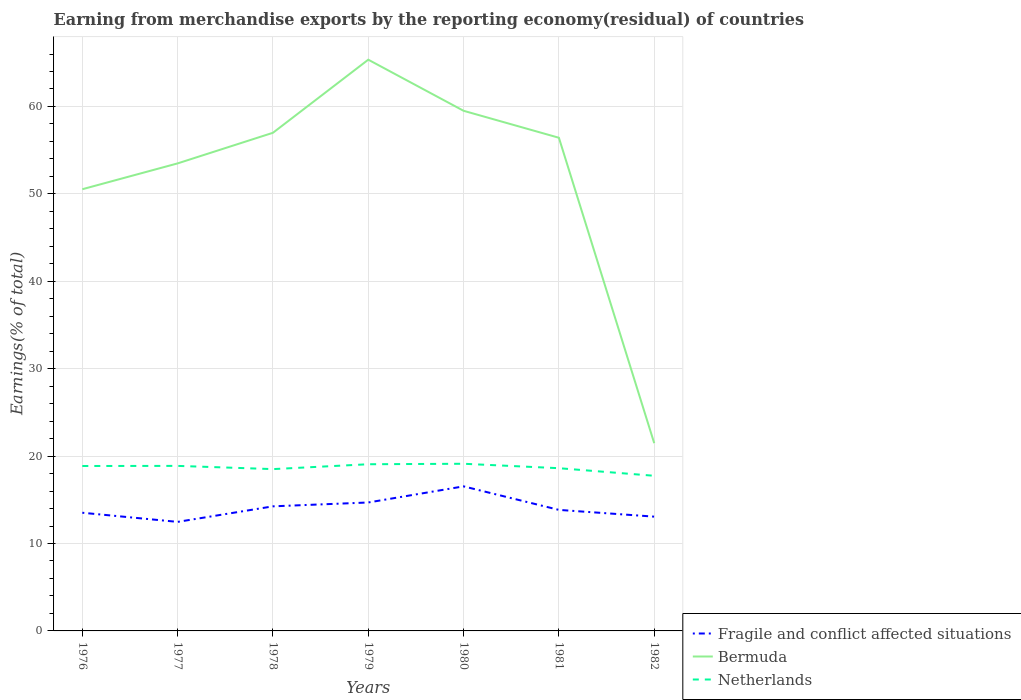How many different coloured lines are there?
Ensure brevity in your answer.  3. Across all years, what is the maximum percentage of amount earned from merchandise exports in Netherlands?
Provide a succinct answer. 17.75. In which year was the percentage of amount earned from merchandise exports in Netherlands maximum?
Your response must be concise. 1982. What is the total percentage of amount earned from merchandise exports in Fragile and conflict affected situations in the graph?
Make the answer very short. -0.73. What is the difference between the highest and the second highest percentage of amount earned from merchandise exports in Netherlands?
Ensure brevity in your answer.  1.38. Is the percentage of amount earned from merchandise exports in Netherlands strictly greater than the percentage of amount earned from merchandise exports in Bermuda over the years?
Offer a terse response. Yes. What is the difference between two consecutive major ticks on the Y-axis?
Offer a terse response. 10. How many legend labels are there?
Offer a very short reply. 3. What is the title of the graph?
Your answer should be very brief. Earning from merchandise exports by the reporting economy(residual) of countries. Does "Cabo Verde" appear as one of the legend labels in the graph?
Provide a short and direct response. No. What is the label or title of the X-axis?
Make the answer very short. Years. What is the label or title of the Y-axis?
Your response must be concise. Earnings(% of total). What is the Earnings(% of total) in Fragile and conflict affected situations in 1976?
Your answer should be very brief. 13.52. What is the Earnings(% of total) of Bermuda in 1976?
Your response must be concise. 50.53. What is the Earnings(% of total) of Netherlands in 1976?
Your answer should be compact. 18.87. What is the Earnings(% of total) of Fragile and conflict affected situations in 1977?
Provide a short and direct response. 12.48. What is the Earnings(% of total) in Bermuda in 1977?
Offer a terse response. 53.49. What is the Earnings(% of total) in Netherlands in 1977?
Offer a very short reply. 18.88. What is the Earnings(% of total) of Fragile and conflict affected situations in 1978?
Provide a succinct answer. 14.25. What is the Earnings(% of total) of Bermuda in 1978?
Make the answer very short. 56.99. What is the Earnings(% of total) in Netherlands in 1978?
Your response must be concise. 18.51. What is the Earnings(% of total) in Fragile and conflict affected situations in 1979?
Offer a very short reply. 14.69. What is the Earnings(% of total) of Bermuda in 1979?
Your answer should be very brief. 65.35. What is the Earnings(% of total) in Netherlands in 1979?
Give a very brief answer. 19.07. What is the Earnings(% of total) of Fragile and conflict affected situations in 1980?
Provide a short and direct response. 16.54. What is the Earnings(% of total) of Bermuda in 1980?
Keep it short and to the point. 59.51. What is the Earnings(% of total) in Netherlands in 1980?
Keep it short and to the point. 19.12. What is the Earnings(% of total) of Fragile and conflict affected situations in 1981?
Make the answer very short. 13.85. What is the Earnings(% of total) in Bermuda in 1981?
Offer a very short reply. 56.42. What is the Earnings(% of total) of Netherlands in 1981?
Your answer should be very brief. 18.62. What is the Earnings(% of total) in Fragile and conflict affected situations in 1982?
Give a very brief answer. 13.07. What is the Earnings(% of total) of Bermuda in 1982?
Provide a succinct answer. 21.48. What is the Earnings(% of total) in Netherlands in 1982?
Your answer should be very brief. 17.75. Across all years, what is the maximum Earnings(% of total) in Fragile and conflict affected situations?
Your response must be concise. 16.54. Across all years, what is the maximum Earnings(% of total) of Bermuda?
Your answer should be very brief. 65.35. Across all years, what is the maximum Earnings(% of total) of Netherlands?
Your response must be concise. 19.12. Across all years, what is the minimum Earnings(% of total) of Fragile and conflict affected situations?
Offer a very short reply. 12.48. Across all years, what is the minimum Earnings(% of total) of Bermuda?
Offer a very short reply. 21.48. Across all years, what is the minimum Earnings(% of total) of Netherlands?
Offer a very short reply. 17.75. What is the total Earnings(% of total) in Fragile and conflict affected situations in the graph?
Make the answer very short. 98.4. What is the total Earnings(% of total) in Bermuda in the graph?
Ensure brevity in your answer.  363.77. What is the total Earnings(% of total) of Netherlands in the graph?
Ensure brevity in your answer.  130.82. What is the difference between the Earnings(% of total) of Fragile and conflict affected situations in 1976 and that in 1977?
Provide a short and direct response. 1.05. What is the difference between the Earnings(% of total) in Bermuda in 1976 and that in 1977?
Give a very brief answer. -2.96. What is the difference between the Earnings(% of total) of Netherlands in 1976 and that in 1977?
Keep it short and to the point. -0.01. What is the difference between the Earnings(% of total) of Fragile and conflict affected situations in 1976 and that in 1978?
Offer a very short reply. -0.73. What is the difference between the Earnings(% of total) of Bermuda in 1976 and that in 1978?
Ensure brevity in your answer.  -6.46. What is the difference between the Earnings(% of total) in Netherlands in 1976 and that in 1978?
Make the answer very short. 0.36. What is the difference between the Earnings(% of total) in Fragile and conflict affected situations in 1976 and that in 1979?
Your answer should be very brief. -1.17. What is the difference between the Earnings(% of total) of Bermuda in 1976 and that in 1979?
Provide a succinct answer. -14.82. What is the difference between the Earnings(% of total) of Netherlands in 1976 and that in 1979?
Ensure brevity in your answer.  -0.2. What is the difference between the Earnings(% of total) in Fragile and conflict affected situations in 1976 and that in 1980?
Offer a very short reply. -3.02. What is the difference between the Earnings(% of total) in Bermuda in 1976 and that in 1980?
Ensure brevity in your answer.  -8.97. What is the difference between the Earnings(% of total) of Netherlands in 1976 and that in 1980?
Make the answer very short. -0.26. What is the difference between the Earnings(% of total) of Fragile and conflict affected situations in 1976 and that in 1981?
Your response must be concise. -0.33. What is the difference between the Earnings(% of total) in Bermuda in 1976 and that in 1981?
Your answer should be compact. -5.89. What is the difference between the Earnings(% of total) in Netherlands in 1976 and that in 1981?
Provide a short and direct response. 0.25. What is the difference between the Earnings(% of total) of Fragile and conflict affected situations in 1976 and that in 1982?
Your response must be concise. 0.45. What is the difference between the Earnings(% of total) of Bermuda in 1976 and that in 1982?
Provide a short and direct response. 29.05. What is the difference between the Earnings(% of total) in Netherlands in 1976 and that in 1982?
Your answer should be compact. 1.12. What is the difference between the Earnings(% of total) of Fragile and conflict affected situations in 1977 and that in 1978?
Your answer should be very brief. -1.78. What is the difference between the Earnings(% of total) of Bermuda in 1977 and that in 1978?
Provide a short and direct response. -3.5. What is the difference between the Earnings(% of total) in Netherlands in 1977 and that in 1978?
Provide a succinct answer. 0.37. What is the difference between the Earnings(% of total) in Fragile and conflict affected situations in 1977 and that in 1979?
Provide a short and direct response. -2.22. What is the difference between the Earnings(% of total) of Bermuda in 1977 and that in 1979?
Your response must be concise. -11.86. What is the difference between the Earnings(% of total) of Netherlands in 1977 and that in 1979?
Your response must be concise. -0.19. What is the difference between the Earnings(% of total) in Fragile and conflict affected situations in 1977 and that in 1980?
Your response must be concise. -4.06. What is the difference between the Earnings(% of total) of Bermuda in 1977 and that in 1980?
Offer a terse response. -6.02. What is the difference between the Earnings(% of total) in Netherlands in 1977 and that in 1980?
Your answer should be compact. -0.24. What is the difference between the Earnings(% of total) in Fragile and conflict affected situations in 1977 and that in 1981?
Offer a very short reply. -1.37. What is the difference between the Earnings(% of total) of Bermuda in 1977 and that in 1981?
Give a very brief answer. -2.93. What is the difference between the Earnings(% of total) in Netherlands in 1977 and that in 1981?
Give a very brief answer. 0.26. What is the difference between the Earnings(% of total) in Fragile and conflict affected situations in 1977 and that in 1982?
Ensure brevity in your answer.  -0.6. What is the difference between the Earnings(% of total) of Bermuda in 1977 and that in 1982?
Offer a very short reply. 32.01. What is the difference between the Earnings(% of total) in Netherlands in 1977 and that in 1982?
Make the answer very short. 1.13. What is the difference between the Earnings(% of total) in Fragile and conflict affected situations in 1978 and that in 1979?
Offer a terse response. -0.44. What is the difference between the Earnings(% of total) of Bermuda in 1978 and that in 1979?
Ensure brevity in your answer.  -8.36. What is the difference between the Earnings(% of total) of Netherlands in 1978 and that in 1979?
Your response must be concise. -0.56. What is the difference between the Earnings(% of total) in Fragile and conflict affected situations in 1978 and that in 1980?
Your answer should be compact. -2.28. What is the difference between the Earnings(% of total) of Bermuda in 1978 and that in 1980?
Keep it short and to the point. -2.52. What is the difference between the Earnings(% of total) of Netherlands in 1978 and that in 1980?
Your response must be concise. -0.61. What is the difference between the Earnings(% of total) of Fragile and conflict affected situations in 1978 and that in 1981?
Ensure brevity in your answer.  0.41. What is the difference between the Earnings(% of total) in Bermuda in 1978 and that in 1981?
Keep it short and to the point. 0.57. What is the difference between the Earnings(% of total) of Netherlands in 1978 and that in 1981?
Your response must be concise. -0.11. What is the difference between the Earnings(% of total) in Fragile and conflict affected situations in 1978 and that in 1982?
Give a very brief answer. 1.18. What is the difference between the Earnings(% of total) of Bermuda in 1978 and that in 1982?
Keep it short and to the point. 35.51. What is the difference between the Earnings(% of total) of Netherlands in 1978 and that in 1982?
Your response must be concise. 0.76. What is the difference between the Earnings(% of total) in Fragile and conflict affected situations in 1979 and that in 1980?
Ensure brevity in your answer.  -1.84. What is the difference between the Earnings(% of total) in Bermuda in 1979 and that in 1980?
Make the answer very short. 5.85. What is the difference between the Earnings(% of total) in Netherlands in 1979 and that in 1980?
Provide a short and direct response. -0.05. What is the difference between the Earnings(% of total) in Fragile and conflict affected situations in 1979 and that in 1981?
Make the answer very short. 0.85. What is the difference between the Earnings(% of total) of Bermuda in 1979 and that in 1981?
Your response must be concise. 8.93. What is the difference between the Earnings(% of total) of Netherlands in 1979 and that in 1981?
Offer a very short reply. 0.45. What is the difference between the Earnings(% of total) of Fragile and conflict affected situations in 1979 and that in 1982?
Make the answer very short. 1.62. What is the difference between the Earnings(% of total) of Bermuda in 1979 and that in 1982?
Make the answer very short. 43.87. What is the difference between the Earnings(% of total) in Netherlands in 1979 and that in 1982?
Offer a terse response. 1.32. What is the difference between the Earnings(% of total) of Fragile and conflict affected situations in 1980 and that in 1981?
Offer a terse response. 2.69. What is the difference between the Earnings(% of total) in Bermuda in 1980 and that in 1981?
Ensure brevity in your answer.  3.08. What is the difference between the Earnings(% of total) in Netherlands in 1980 and that in 1981?
Make the answer very short. 0.51. What is the difference between the Earnings(% of total) in Fragile and conflict affected situations in 1980 and that in 1982?
Offer a very short reply. 3.46. What is the difference between the Earnings(% of total) in Bermuda in 1980 and that in 1982?
Your answer should be compact. 38.03. What is the difference between the Earnings(% of total) in Netherlands in 1980 and that in 1982?
Keep it short and to the point. 1.38. What is the difference between the Earnings(% of total) in Fragile and conflict affected situations in 1981 and that in 1982?
Give a very brief answer. 0.77. What is the difference between the Earnings(% of total) of Bermuda in 1981 and that in 1982?
Make the answer very short. 34.94. What is the difference between the Earnings(% of total) in Netherlands in 1981 and that in 1982?
Offer a terse response. 0.87. What is the difference between the Earnings(% of total) of Fragile and conflict affected situations in 1976 and the Earnings(% of total) of Bermuda in 1977?
Keep it short and to the point. -39.97. What is the difference between the Earnings(% of total) in Fragile and conflict affected situations in 1976 and the Earnings(% of total) in Netherlands in 1977?
Give a very brief answer. -5.36. What is the difference between the Earnings(% of total) of Bermuda in 1976 and the Earnings(% of total) of Netherlands in 1977?
Provide a succinct answer. 31.65. What is the difference between the Earnings(% of total) in Fragile and conflict affected situations in 1976 and the Earnings(% of total) in Bermuda in 1978?
Keep it short and to the point. -43.47. What is the difference between the Earnings(% of total) of Fragile and conflict affected situations in 1976 and the Earnings(% of total) of Netherlands in 1978?
Offer a very short reply. -4.99. What is the difference between the Earnings(% of total) in Bermuda in 1976 and the Earnings(% of total) in Netherlands in 1978?
Offer a very short reply. 32.02. What is the difference between the Earnings(% of total) in Fragile and conflict affected situations in 1976 and the Earnings(% of total) in Bermuda in 1979?
Ensure brevity in your answer.  -51.83. What is the difference between the Earnings(% of total) of Fragile and conflict affected situations in 1976 and the Earnings(% of total) of Netherlands in 1979?
Provide a short and direct response. -5.55. What is the difference between the Earnings(% of total) of Bermuda in 1976 and the Earnings(% of total) of Netherlands in 1979?
Your answer should be very brief. 31.46. What is the difference between the Earnings(% of total) of Fragile and conflict affected situations in 1976 and the Earnings(% of total) of Bermuda in 1980?
Ensure brevity in your answer.  -45.99. What is the difference between the Earnings(% of total) of Fragile and conflict affected situations in 1976 and the Earnings(% of total) of Netherlands in 1980?
Your answer should be very brief. -5.6. What is the difference between the Earnings(% of total) of Bermuda in 1976 and the Earnings(% of total) of Netherlands in 1980?
Your answer should be compact. 31.41. What is the difference between the Earnings(% of total) of Fragile and conflict affected situations in 1976 and the Earnings(% of total) of Bermuda in 1981?
Offer a very short reply. -42.9. What is the difference between the Earnings(% of total) in Fragile and conflict affected situations in 1976 and the Earnings(% of total) in Netherlands in 1981?
Make the answer very short. -5.1. What is the difference between the Earnings(% of total) of Bermuda in 1976 and the Earnings(% of total) of Netherlands in 1981?
Make the answer very short. 31.91. What is the difference between the Earnings(% of total) in Fragile and conflict affected situations in 1976 and the Earnings(% of total) in Bermuda in 1982?
Keep it short and to the point. -7.96. What is the difference between the Earnings(% of total) in Fragile and conflict affected situations in 1976 and the Earnings(% of total) in Netherlands in 1982?
Ensure brevity in your answer.  -4.23. What is the difference between the Earnings(% of total) in Bermuda in 1976 and the Earnings(% of total) in Netherlands in 1982?
Your answer should be compact. 32.78. What is the difference between the Earnings(% of total) of Fragile and conflict affected situations in 1977 and the Earnings(% of total) of Bermuda in 1978?
Keep it short and to the point. -44.52. What is the difference between the Earnings(% of total) in Fragile and conflict affected situations in 1977 and the Earnings(% of total) in Netherlands in 1978?
Give a very brief answer. -6.04. What is the difference between the Earnings(% of total) in Bermuda in 1977 and the Earnings(% of total) in Netherlands in 1978?
Provide a succinct answer. 34.98. What is the difference between the Earnings(% of total) in Fragile and conflict affected situations in 1977 and the Earnings(% of total) in Bermuda in 1979?
Keep it short and to the point. -52.88. What is the difference between the Earnings(% of total) in Fragile and conflict affected situations in 1977 and the Earnings(% of total) in Netherlands in 1979?
Your answer should be compact. -6.59. What is the difference between the Earnings(% of total) of Bermuda in 1977 and the Earnings(% of total) of Netherlands in 1979?
Offer a very short reply. 34.42. What is the difference between the Earnings(% of total) of Fragile and conflict affected situations in 1977 and the Earnings(% of total) of Bermuda in 1980?
Offer a terse response. -47.03. What is the difference between the Earnings(% of total) of Fragile and conflict affected situations in 1977 and the Earnings(% of total) of Netherlands in 1980?
Provide a short and direct response. -6.65. What is the difference between the Earnings(% of total) of Bermuda in 1977 and the Earnings(% of total) of Netherlands in 1980?
Give a very brief answer. 34.36. What is the difference between the Earnings(% of total) of Fragile and conflict affected situations in 1977 and the Earnings(% of total) of Bermuda in 1981?
Offer a terse response. -43.95. What is the difference between the Earnings(% of total) in Fragile and conflict affected situations in 1977 and the Earnings(% of total) in Netherlands in 1981?
Keep it short and to the point. -6.14. What is the difference between the Earnings(% of total) in Bermuda in 1977 and the Earnings(% of total) in Netherlands in 1981?
Keep it short and to the point. 34.87. What is the difference between the Earnings(% of total) in Fragile and conflict affected situations in 1977 and the Earnings(% of total) in Bermuda in 1982?
Make the answer very short. -9. What is the difference between the Earnings(% of total) of Fragile and conflict affected situations in 1977 and the Earnings(% of total) of Netherlands in 1982?
Offer a very short reply. -5.27. What is the difference between the Earnings(% of total) of Bermuda in 1977 and the Earnings(% of total) of Netherlands in 1982?
Offer a terse response. 35.74. What is the difference between the Earnings(% of total) in Fragile and conflict affected situations in 1978 and the Earnings(% of total) in Bermuda in 1979?
Keep it short and to the point. -51.1. What is the difference between the Earnings(% of total) of Fragile and conflict affected situations in 1978 and the Earnings(% of total) of Netherlands in 1979?
Keep it short and to the point. -4.82. What is the difference between the Earnings(% of total) in Bermuda in 1978 and the Earnings(% of total) in Netherlands in 1979?
Make the answer very short. 37.92. What is the difference between the Earnings(% of total) in Fragile and conflict affected situations in 1978 and the Earnings(% of total) in Bermuda in 1980?
Give a very brief answer. -45.25. What is the difference between the Earnings(% of total) in Fragile and conflict affected situations in 1978 and the Earnings(% of total) in Netherlands in 1980?
Your response must be concise. -4.87. What is the difference between the Earnings(% of total) in Bermuda in 1978 and the Earnings(% of total) in Netherlands in 1980?
Your answer should be compact. 37.87. What is the difference between the Earnings(% of total) in Fragile and conflict affected situations in 1978 and the Earnings(% of total) in Bermuda in 1981?
Offer a very short reply. -42.17. What is the difference between the Earnings(% of total) in Fragile and conflict affected situations in 1978 and the Earnings(% of total) in Netherlands in 1981?
Provide a short and direct response. -4.36. What is the difference between the Earnings(% of total) in Bermuda in 1978 and the Earnings(% of total) in Netherlands in 1981?
Ensure brevity in your answer.  38.37. What is the difference between the Earnings(% of total) in Fragile and conflict affected situations in 1978 and the Earnings(% of total) in Bermuda in 1982?
Offer a very short reply. -7.23. What is the difference between the Earnings(% of total) in Fragile and conflict affected situations in 1978 and the Earnings(% of total) in Netherlands in 1982?
Provide a short and direct response. -3.49. What is the difference between the Earnings(% of total) in Bermuda in 1978 and the Earnings(% of total) in Netherlands in 1982?
Your response must be concise. 39.24. What is the difference between the Earnings(% of total) in Fragile and conflict affected situations in 1979 and the Earnings(% of total) in Bermuda in 1980?
Your answer should be very brief. -44.81. What is the difference between the Earnings(% of total) of Fragile and conflict affected situations in 1979 and the Earnings(% of total) of Netherlands in 1980?
Give a very brief answer. -4.43. What is the difference between the Earnings(% of total) in Bermuda in 1979 and the Earnings(% of total) in Netherlands in 1980?
Provide a succinct answer. 46.23. What is the difference between the Earnings(% of total) of Fragile and conflict affected situations in 1979 and the Earnings(% of total) of Bermuda in 1981?
Offer a terse response. -41.73. What is the difference between the Earnings(% of total) of Fragile and conflict affected situations in 1979 and the Earnings(% of total) of Netherlands in 1981?
Provide a short and direct response. -3.92. What is the difference between the Earnings(% of total) of Bermuda in 1979 and the Earnings(% of total) of Netherlands in 1981?
Provide a succinct answer. 46.74. What is the difference between the Earnings(% of total) of Fragile and conflict affected situations in 1979 and the Earnings(% of total) of Bermuda in 1982?
Keep it short and to the point. -6.79. What is the difference between the Earnings(% of total) in Fragile and conflict affected situations in 1979 and the Earnings(% of total) in Netherlands in 1982?
Give a very brief answer. -3.05. What is the difference between the Earnings(% of total) in Bermuda in 1979 and the Earnings(% of total) in Netherlands in 1982?
Ensure brevity in your answer.  47.6. What is the difference between the Earnings(% of total) of Fragile and conflict affected situations in 1980 and the Earnings(% of total) of Bermuda in 1981?
Provide a short and direct response. -39.88. What is the difference between the Earnings(% of total) of Fragile and conflict affected situations in 1980 and the Earnings(% of total) of Netherlands in 1981?
Provide a short and direct response. -2.08. What is the difference between the Earnings(% of total) in Bermuda in 1980 and the Earnings(% of total) in Netherlands in 1981?
Your response must be concise. 40.89. What is the difference between the Earnings(% of total) of Fragile and conflict affected situations in 1980 and the Earnings(% of total) of Bermuda in 1982?
Offer a terse response. -4.94. What is the difference between the Earnings(% of total) of Fragile and conflict affected situations in 1980 and the Earnings(% of total) of Netherlands in 1982?
Provide a succinct answer. -1.21. What is the difference between the Earnings(% of total) in Bermuda in 1980 and the Earnings(% of total) in Netherlands in 1982?
Your answer should be very brief. 41.76. What is the difference between the Earnings(% of total) of Fragile and conflict affected situations in 1981 and the Earnings(% of total) of Bermuda in 1982?
Offer a terse response. -7.63. What is the difference between the Earnings(% of total) in Fragile and conflict affected situations in 1981 and the Earnings(% of total) in Netherlands in 1982?
Provide a short and direct response. -3.9. What is the difference between the Earnings(% of total) in Bermuda in 1981 and the Earnings(% of total) in Netherlands in 1982?
Provide a succinct answer. 38.67. What is the average Earnings(% of total) of Fragile and conflict affected situations per year?
Make the answer very short. 14.06. What is the average Earnings(% of total) of Bermuda per year?
Offer a terse response. 51.97. What is the average Earnings(% of total) of Netherlands per year?
Offer a very short reply. 18.69. In the year 1976, what is the difference between the Earnings(% of total) of Fragile and conflict affected situations and Earnings(% of total) of Bermuda?
Provide a succinct answer. -37.01. In the year 1976, what is the difference between the Earnings(% of total) of Fragile and conflict affected situations and Earnings(% of total) of Netherlands?
Provide a succinct answer. -5.35. In the year 1976, what is the difference between the Earnings(% of total) in Bermuda and Earnings(% of total) in Netherlands?
Provide a succinct answer. 31.66. In the year 1977, what is the difference between the Earnings(% of total) in Fragile and conflict affected situations and Earnings(% of total) in Bermuda?
Keep it short and to the point. -41.01. In the year 1977, what is the difference between the Earnings(% of total) of Fragile and conflict affected situations and Earnings(% of total) of Netherlands?
Provide a succinct answer. -6.41. In the year 1977, what is the difference between the Earnings(% of total) in Bermuda and Earnings(% of total) in Netherlands?
Offer a very short reply. 34.61. In the year 1978, what is the difference between the Earnings(% of total) in Fragile and conflict affected situations and Earnings(% of total) in Bermuda?
Offer a terse response. -42.74. In the year 1978, what is the difference between the Earnings(% of total) of Fragile and conflict affected situations and Earnings(% of total) of Netherlands?
Your answer should be compact. -4.26. In the year 1978, what is the difference between the Earnings(% of total) in Bermuda and Earnings(% of total) in Netherlands?
Offer a terse response. 38.48. In the year 1979, what is the difference between the Earnings(% of total) of Fragile and conflict affected situations and Earnings(% of total) of Bermuda?
Provide a short and direct response. -50.66. In the year 1979, what is the difference between the Earnings(% of total) in Fragile and conflict affected situations and Earnings(% of total) in Netherlands?
Ensure brevity in your answer.  -4.37. In the year 1979, what is the difference between the Earnings(% of total) of Bermuda and Earnings(% of total) of Netherlands?
Keep it short and to the point. 46.28. In the year 1980, what is the difference between the Earnings(% of total) of Fragile and conflict affected situations and Earnings(% of total) of Bermuda?
Make the answer very short. -42.97. In the year 1980, what is the difference between the Earnings(% of total) in Fragile and conflict affected situations and Earnings(% of total) in Netherlands?
Keep it short and to the point. -2.59. In the year 1980, what is the difference between the Earnings(% of total) in Bermuda and Earnings(% of total) in Netherlands?
Offer a very short reply. 40.38. In the year 1981, what is the difference between the Earnings(% of total) in Fragile and conflict affected situations and Earnings(% of total) in Bermuda?
Your response must be concise. -42.57. In the year 1981, what is the difference between the Earnings(% of total) of Fragile and conflict affected situations and Earnings(% of total) of Netherlands?
Ensure brevity in your answer.  -4.77. In the year 1981, what is the difference between the Earnings(% of total) of Bermuda and Earnings(% of total) of Netherlands?
Your response must be concise. 37.8. In the year 1982, what is the difference between the Earnings(% of total) in Fragile and conflict affected situations and Earnings(% of total) in Bermuda?
Provide a short and direct response. -8.41. In the year 1982, what is the difference between the Earnings(% of total) in Fragile and conflict affected situations and Earnings(% of total) in Netherlands?
Your response must be concise. -4.67. In the year 1982, what is the difference between the Earnings(% of total) in Bermuda and Earnings(% of total) in Netherlands?
Offer a terse response. 3.73. What is the ratio of the Earnings(% of total) of Fragile and conflict affected situations in 1976 to that in 1977?
Keep it short and to the point. 1.08. What is the ratio of the Earnings(% of total) of Bermuda in 1976 to that in 1977?
Give a very brief answer. 0.94. What is the ratio of the Earnings(% of total) of Fragile and conflict affected situations in 1976 to that in 1978?
Your answer should be very brief. 0.95. What is the ratio of the Earnings(% of total) in Bermuda in 1976 to that in 1978?
Give a very brief answer. 0.89. What is the ratio of the Earnings(% of total) in Netherlands in 1976 to that in 1978?
Your answer should be compact. 1.02. What is the ratio of the Earnings(% of total) of Fragile and conflict affected situations in 1976 to that in 1979?
Provide a succinct answer. 0.92. What is the ratio of the Earnings(% of total) of Bermuda in 1976 to that in 1979?
Your answer should be very brief. 0.77. What is the ratio of the Earnings(% of total) in Netherlands in 1976 to that in 1979?
Your answer should be very brief. 0.99. What is the ratio of the Earnings(% of total) in Fragile and conflict affected situations in 1976 to that in 1980?
Your answer should be very brief. 0.82. What is the ratio of the Earnings(% of total) in Bermuda in 1976 to that in 1980?
Your answer should be very brief. 0.85. What is the ratio of the Earnings(% of total) in Netherlands in 1976 to that in 1980?
Keep it short and to the point. 0.99. What is the ratio of the Earnings(% of total) in Fragile and conflict affected situations in 1976 to that in 1981?
Your answer should be very brief. 0.98. What is the ratio of the Earnings(% of total) in Bermuda in 1976 to that in 1981?
Your answer should be compact. 0.9. What is the ratio of the Earnings(% of total) in Netherlands in 1976 to that in 1981?
Provide a short and direct response. 1.01. What is the ratio of the Earnings(% of total) of Fragile and conflict affected situations in 1976 to that in 1982?
Your response must be concise. 1.03. What is the ratio of the Earnings(% of total) of Bermuda in 1976 to that in 1982?
Your response must be concise. 2.35. What is the ratio of the Earnings(% of total) in Netherlands in 1976 to that in 1982?
Provide a succinct answer. 1.06. What is the ratio of the Earnings(% of total) in Fragile and conflict affected situations in 1977 to that in 1978?
Keep it short and to the point. 0.88. What is the ratio of the Earnings(% of total) of Bermuda in 1977 to that in 1978?
Keep it short and to the point. 0.94. What is the ratio of the Earnings(% of total) of Netherlands in 1977 to that in 1978?
Provide a succinct answer. 1.02. What is the ratio of the Earnings(% of total) of Fragile and conflict affected situations in 1977 to that in 1979?
Make the answer very short. 0.85. What is the ratio of the Earnings(% of total) in Bermuda in 1977 to that in 1979?
Ensure brevity in your answer.  0.82. What is the ratio of the Earnings(% of total) in Fragile and conflict affected situations in 1977 to that in 1980?
Offer a terse response. 0.75. What is the ratio of the Earnings(% of total) in Bermuda in 1977 to that in 1980?
Make the answer very short. 0.9. What is the ratio of the Earnings(% of total) in Netherlands in 1977 to that in 1980?
Your answer should be compact. 0.99. What is the ratio of the Earnings(% of total) of Fragile and conflict affected situations in 1977 to that in 1981?
Provide a short and direct response. 0.9. What is the ratio of the Earnings(% of total) in Bermuda in 1977 to that in 1981?
Give a very brief answer. 0.95. What is the ratio of the Earnings(% of total) of Netherlands in 1977 to that in 1981?
Provide a short and direct response. 1.01. What is the ratio of the Earnings(% of total) of Fragile and conflict affected situations in 1977 to that in 1982?
Offer a terse response. 0.95. What is the ratio of the Earnings(% of total) in Bermuda in 1977 to that in 1982?
Give a very brief answer. 2.49. What is the ratio of the Earnings(% of total) in Netherlands in 1977 to that in 1982?
Offer a terse response. 1.06. What is the ratio of the Earnings(% of total) in Bermuda in 1978 to that in 1979?
Ensure brevity in your answer.  0.87. What is the ratio of the Earnings(% of total) in Netherlands in 1978 to that in 1979?
Give a very brief answer. 0.97. What is the ratio of the Earnings(% of total) in Fragile and conflict affected situations in 1978 to that in 1980?
Provide a succinct answer. 0.86. What is the ratio of the Earnings(% of total) of Bermuda in 1978 to that in 1980?
Your response must be concise. 0.96. What is the ratio of the Earnings(% of total) of Fragile and conflict affected situations in 1978 to that in 1981?
Your answer should be very brief. 1.03. What is the ratio of the Earnings(% of total) of Netherlands in 1978 to that in 1981?
Your answer should be very brief. 0.99. What is the ratio of the Earnings(% of total) of Fragile and conflict affected situations in 1978 to that in 1982?
Keep it short and to the point. 1.09. What is the ratio of the Earnings(% of total) in Bermuda in 1978 to that in 1982?
Offer a terse response. 2.65. What is the ratio of the Earnings(% of total) of Netherlands in 1978 to that in 1982?
Make the answer very short. 1.04. What is the ratio of the Earnings(% of total) of Fragile and conflict affected situations in 1979 to that in 1980?
Ensure brevity in your answer.  0.89. What is the ratio of the Earnings(% of total) in Bermuda in 1979 to that in 1980?
Your answer should be very brief. 1.1. What is the ratio of the Earnings(% of total) in Fragile and conflict affected situations in 1979 to that in 1981?
Ensure brevity in your answer.  1.06. What is the ratio of the Earnings(% of total) of Bermuda in 1979 to that in 1981?
Offer a terse response. 1.16. What is the ratio of the Earnings(% of total) in Netherlands in 1979 to that in 1981?
Your answer should be compact. 1.02. What is the ratio of the Earnings(% of total) in Fragile and conflict affected situations in 1979 to that in 1982?
Provide a succinct answer. 1.12. What is the ratio of the Earnings(% of total) of Bermuda in 1979 to that in 1982?
Give a very brief answer. 3.04. What is the ratio of the Earnings(% of total) of Netherlands in 1979 to that in 1982?
Your answer should be compact. 1.07. What is the ratio of the Earnings(% of total) of Fragile and conflict affected situations in 1980 to that in 1981?
Make the answer very short. 1.19. What is the ratio of the Earnings(% of total) of Bermuda in 1980 to that in 1981?
Your response must be concise. 1.05. What is the ratio of the Earnings(% of total) in Netherlands in 1980 to that in 1981?
Make the answer very short. 1.03. What is the ratio of the Earnings(% of total) in Fragile and conflict affected situations in 1980 to that in 1982?
Your answer should be very brief. 1.26. What is the ratio of the Earnings(% of total) of Bermuda in 1980 to that in 1982?
Ensure brevity in your answer.  2.77. What is the ratio of the Earnings(% of total) in Netherlands in 1980 to that in 1982?
Your response must be concise. 1.08. What is the ratio of the Earnings(% of total) in Fragile and conflict affected situations in 1981 to that in 1982?
Your answer should be very brief. 1.06. What is the ratio of the Earnings(% of total) of Bermuda in 1981 to that in 1982?
Offer a very short reply. 2.63. What is the ratio of the Earnings(% of total) in Netherlands in 1981 to that in 1982?
Offer a terse response. 1.05. What is the difference between the highest and the second highest Earnings(% of total) of Fragile and conflict affected situations?
Your answer should be compact. 1.84. What is the difference between the highest and the second highest Earnings(% of total) in Bermuda?
Provide a succinct answer. 5.85. What is the difference between the highest and the second highest Earnings(% of total) in Netherlands?
Your response must be concise. 0.05. What is the difference between the highest and the lowest Earnings(% of total) of Fragile and conflict affected situations?
Keep it short and to the point. 4.06. What is the difference between the highest and the lowest Earnings(% of total) in Bermuda?
Make the answer very short. 43.87. What is the difference between the highest and the lowest Earnings(% of total) in Netherlands?
Your answer should be very brief. 1.38. 